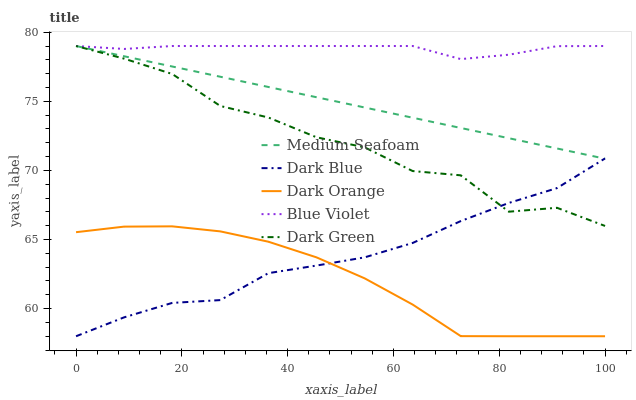Does Dark Orange have the minimum area under the curve?
Answer yes or no. Yes. Does Blue Violet have the maximum area under the curve?
Answer yes or no. Yes. Does Dark Green have the minimum area under the curve?
Answer yes or no. No. Does Dark Green have the maximum area under the curve?
Answer yes or no. No. Is Medium Seafoam the smoothest?
Answer yes or no. Yes. Is Dark Green the roughest?
Answer yes or no. Yes. Is Dark Green the smoothest?
Answer yes or no. No. Is Medium Seafoam the roughest?
Answer yes or no. No. Does Dark Green have the lowest value?
Answer yes or no. No. Does Blue Violet have the highest value?
Answer yes or no. Yes. Does Dark Orange have the highest value?
Answer yes or no. No. Is Dark Orange less than Blue Violet?
Answer yes or no. Yes. Is Blue Violet greater than Dark Orange?
Answer yes or no. Yes. Does Dark Green intersect Medium Seafoam?
Answer yes or no. Yes. Is Dark Green less than Medium Seafoam?
Answer yes or no. No. Is Dark Green greater than Medium Seafoam?
Answer yes or no. No. Does Dark Orange intersect Blue Violet?
Answer yes or no. No. 